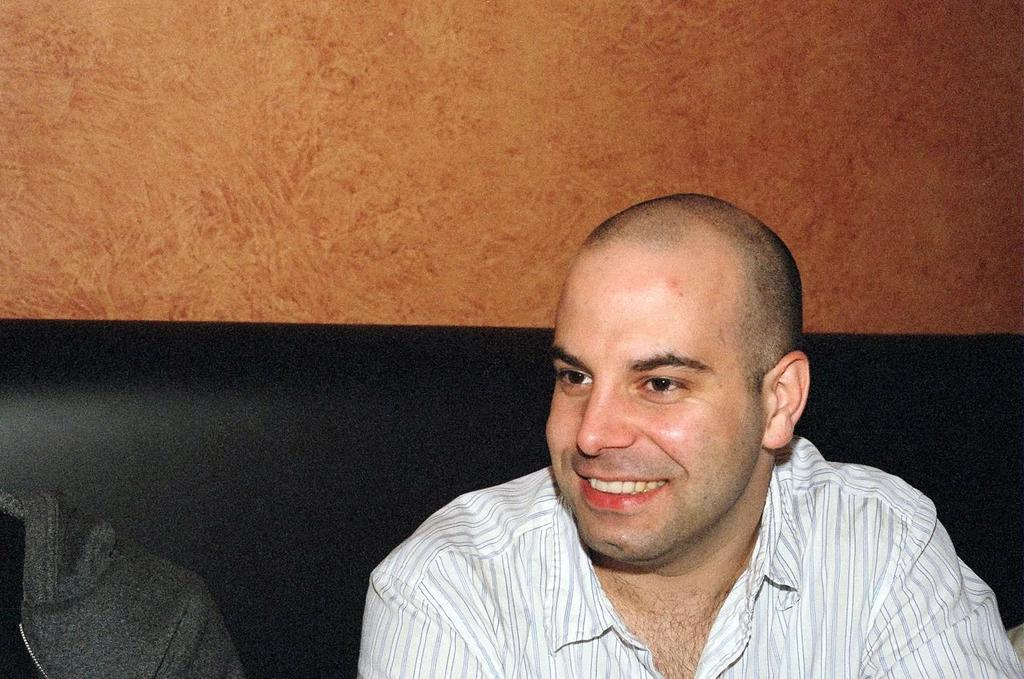How many people are in the image? There are two people in the image. What are the people doing in the image? The people are sitting on a couch. What colors are the dresses of the two people? One person is wearing a white dress, and the other person is wearing a grey dress. What color is the wall in the background? The wall in the background is brown. What type of grape is being used to decorate the cake in the image? There is no cake or grapes present in the image. 